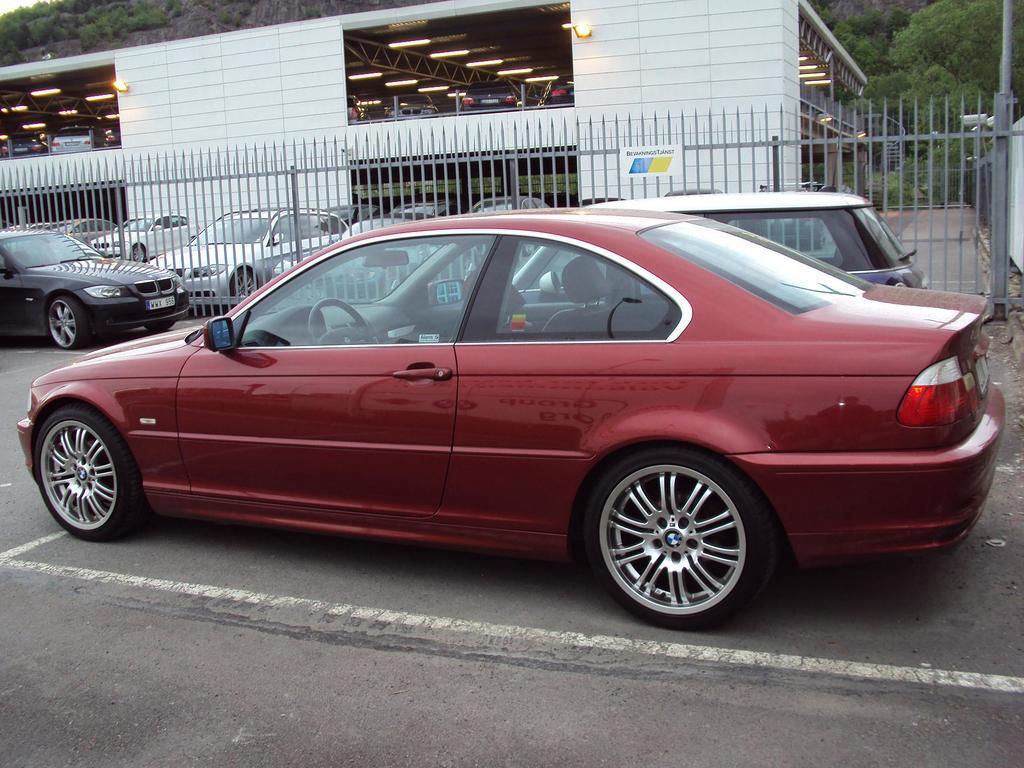Could you give a brief overview of what you see in this image? In this image there is a car on a road, behind that car there is a fencing, in the background there are cars and shed and a mountain. 